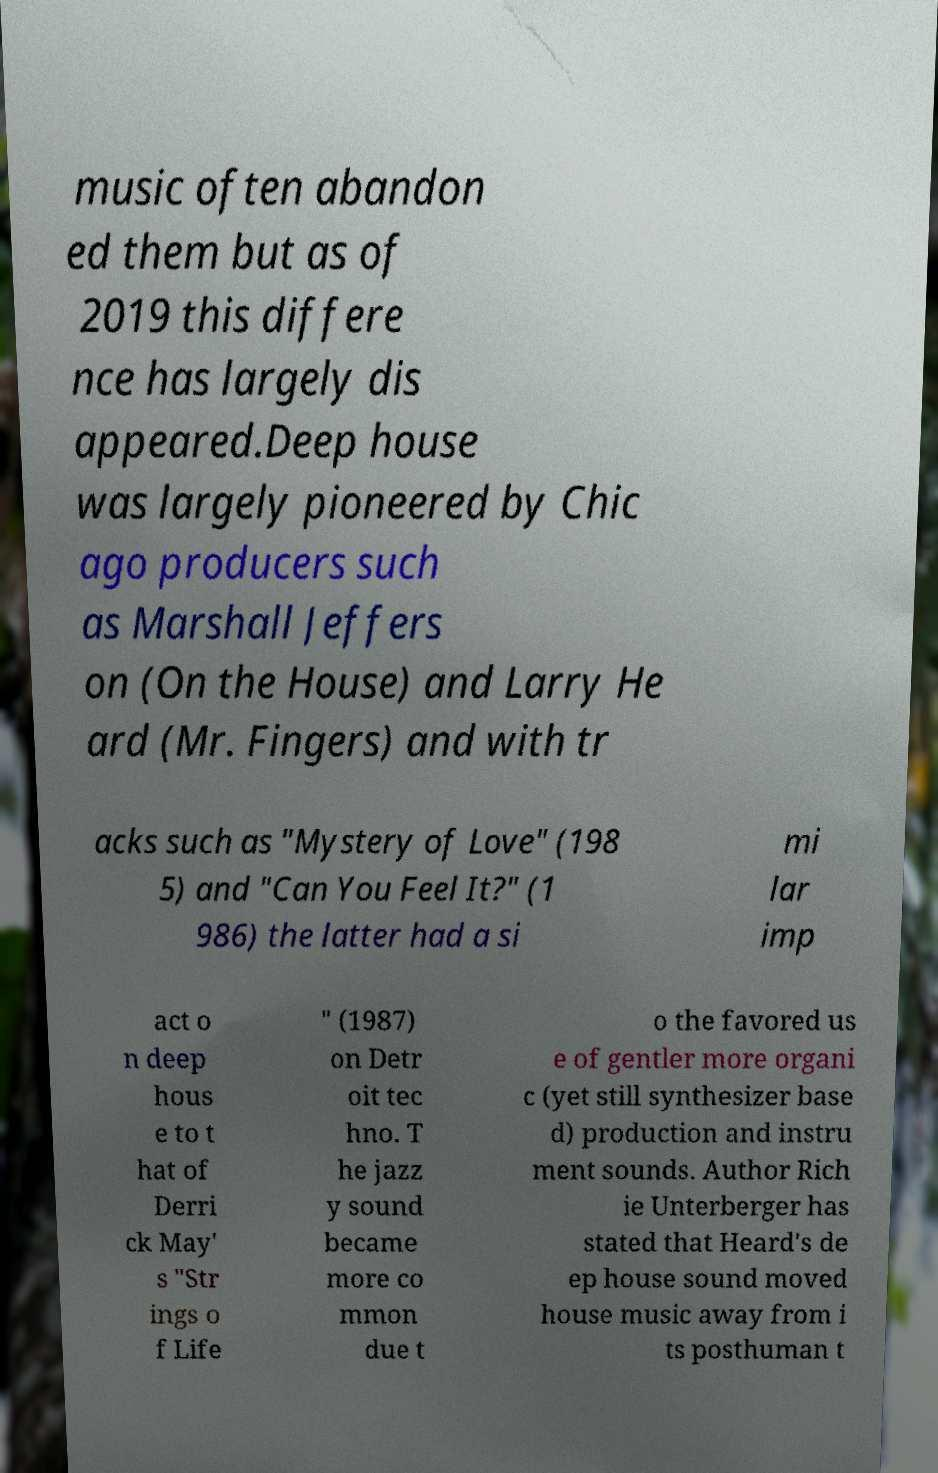For documentation purposes, I need the text within this image transcribed. Could you provide that? music often abandon ed them but as of 2019 this differe nce has largely dis appeared.Deep house was largely pioneered by Chic ago producers such as Marshall Jeffers on (On the House) and Larry He ard (Mr. Fingers) and with tr acks such as "Mystery of Love" (198 5) and "Can You Feel It?" (1 986) the latter had a si mi lar imp act o n deep hous e to t hat of Derri ck May' s "Str ings o f Life " (1987) on Detr oit tec hno. T he jazz y sound became more co mmon due t o the favored us e of gentler more organi c (yet still synthesizer base d) production and instru ment sounds. Author Rich ie Unterberger has stated that Heard's de ep house sound moved house music away from i ts posthuman t 